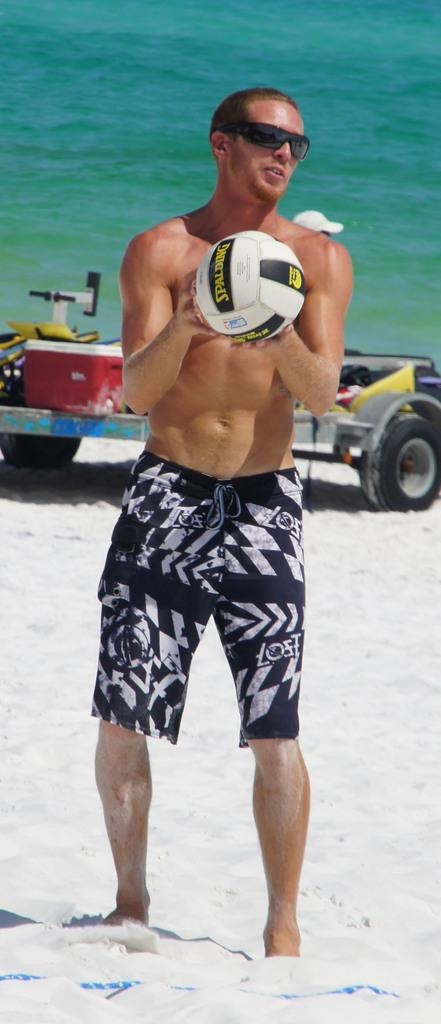What is the person in the image wearing? The person is wearing black shorts in the image. What is the person holding in the image? The person is holding a ball in the image. Where is the image set? The image is set at a beach. What can be seen in the background of the image? There is a motor visible in the background. What is the name of the bed in the image? There is no bed present in the image. 